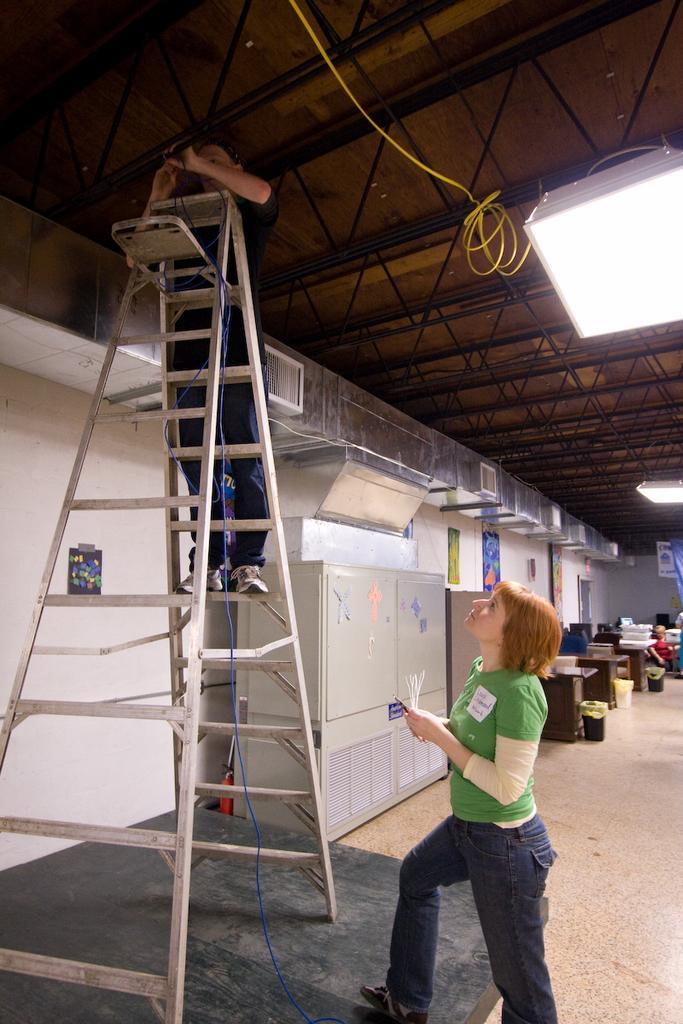Please provide a concise description of this image. In this picture I can see a person standing on the ladder, down one woman is standing and watching, behind I can see few objects. 